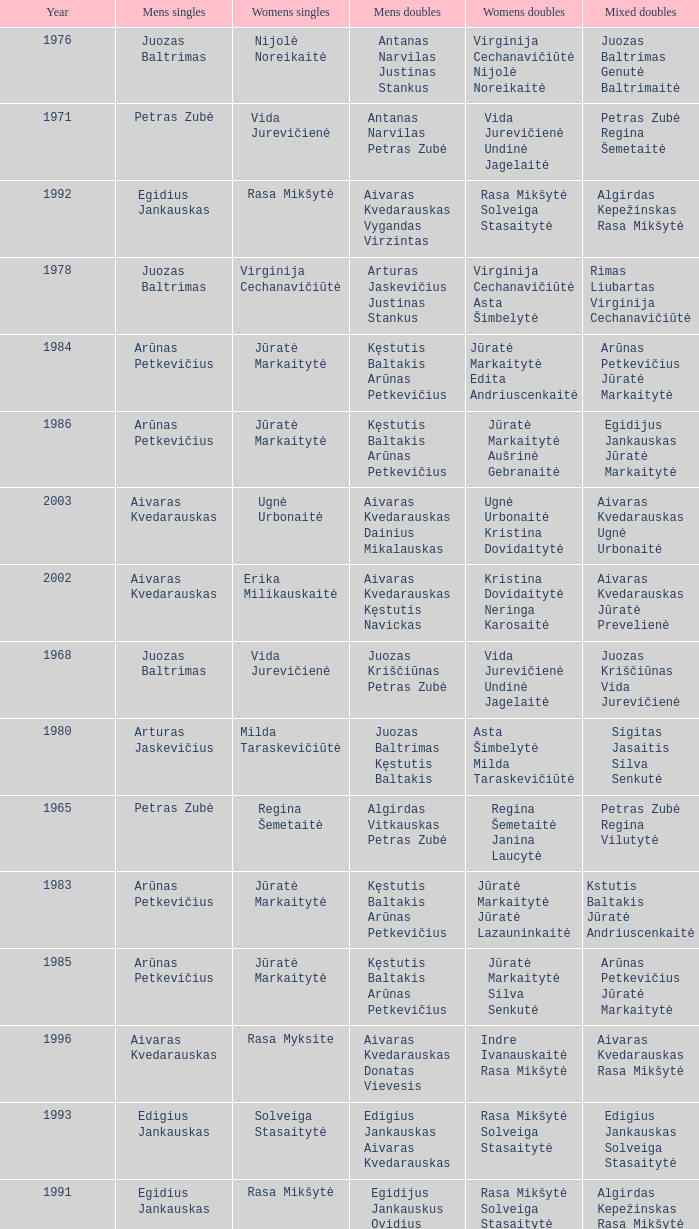What was the first year of the Lithuanian National Badminton Championships? 1963.0. 